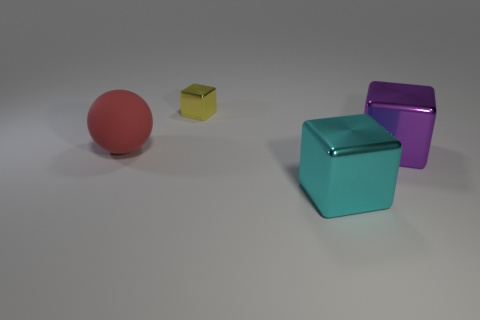Subtract all large shiny blocks. How many blocks are left? 1 Add 2 purple cylinders. How many objects exist? 6 Subtract 3 cubes. How many cubes are left? 0 Subtract all green cylinders. How many cyan blocks are left? 1 Subtract all brown metal things. Subtract all red rubber balls. How many objects are left? 3 Add 2 tiny yellow blocks. How many tiny yellow blocks are left? 3 Add 1 shiny cubes. How many shiny cubes exist? 4 Subtract all yellow blocks. How many blocks are left? 2 Subtract 1 purple blocks. How many objects are left? 3 Subtract all blocks. How many objects are left? 1 